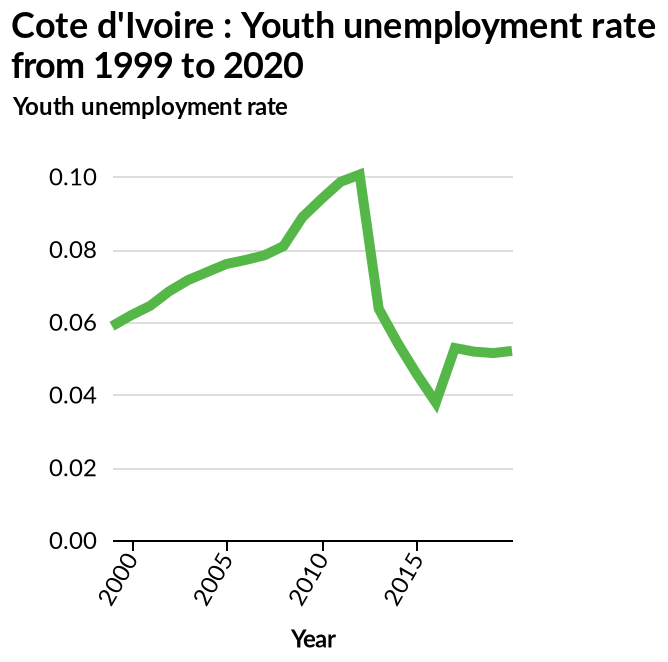<image>
What trend did youth employment experience from 2010 to 2016?  Youth employment saw a sharp decline from 2010 to 2016. What is plotted on the y-axis in the line diagram? The y-axis plots the youth unemployment rate. What is the highest recorded youth unemployment rate in Cote d'Ivoire during the given time period? To be determined based on the data. 